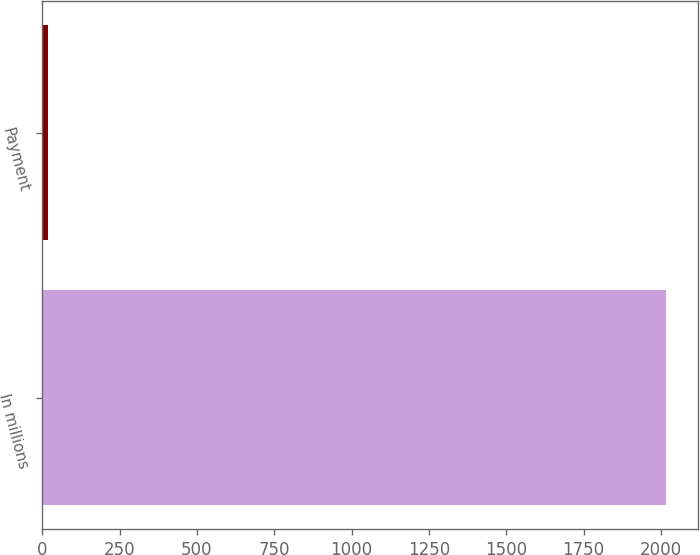Convert chart to OTSL. <chart><loc_0><loc_0><loc_500><loc_500><bar_chart><fcel>In millions<fcel>Payment<nl><fcel>2018<fcel>17<nl></chart> 